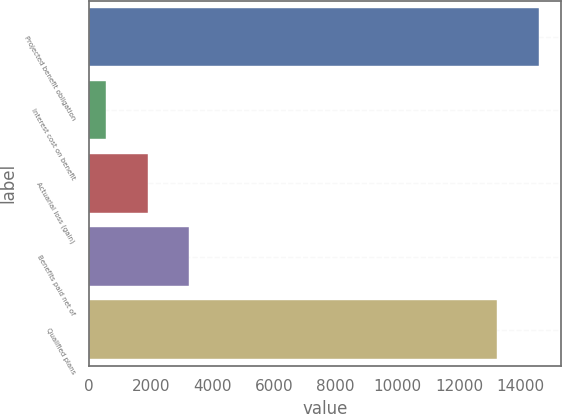Convert chart to OTSL. <chart><loc_0><loc_0><loc_500><loc_500><bar_chart><fcel>Projected benefit obligation<fcel>Interest cost on benefit<fcel>Actuarial loss (gain)<fcel>Benefits paid net of<fcel>Qualified plans<nl><fcel>14581.7<fcel>553<fcel>1903.7<fcel>3254.4<fcel>13231<nl></chart> 